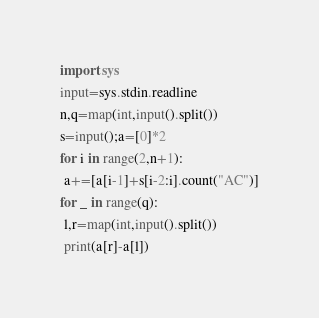<code> <loc_0><loc_0><loc_500><loc_500><_Python_>import sys
input=sys.stdin.readline
n,q=map(int,input().split())
s=input();a=[0]*2
for i in range(2,n+1):
 a+=[a[i-1]+s[i-2:i].count("AC")]
for _ in range(q):
 l,r=map(int,input().split())
 print(a[r]-a[l])</code> 